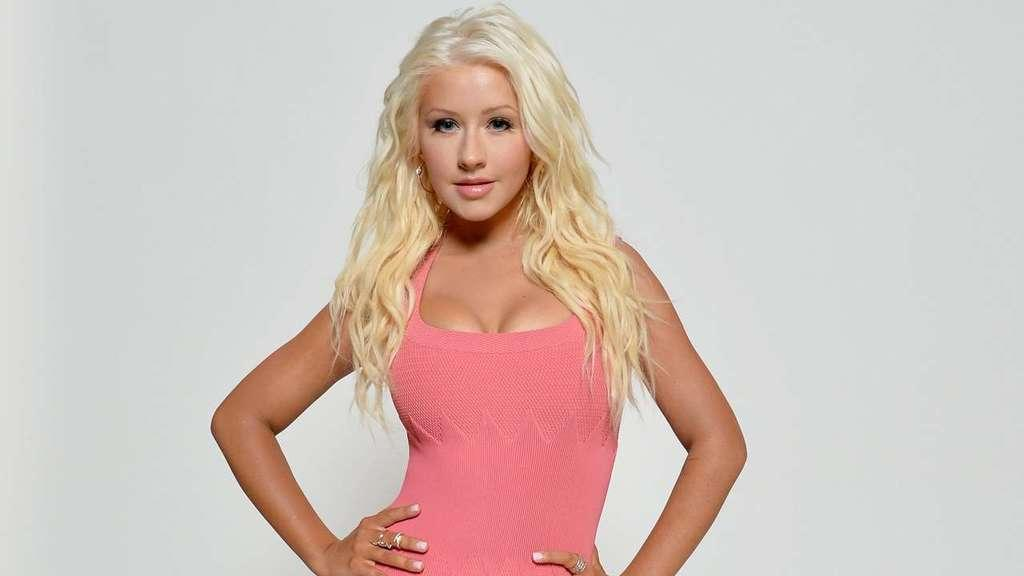What is the main subject of the picture? The main subject of the picture is a woman. What is the woman doing in the picture? The woman is standing with her hands on her hips. What is the woman wearing in the picture? The woman is wearing a pink top. What is the color of the woman's hair? The woman has cream-colored hair. What can be seen in the background of the picture? There is a white color surface in the background. What type of voice can be heard coming from the woman in the image? There is no voice present in the image, as it is a still photograph. What scent is associated with the woman in the image? There is no scent associated with the woman in the image, as it is a still photograph. 